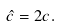Convert formula to latex. <formula><loc_0><loc_0><loc_500><loc_500>\hat { c } = 2 c .</formula> 